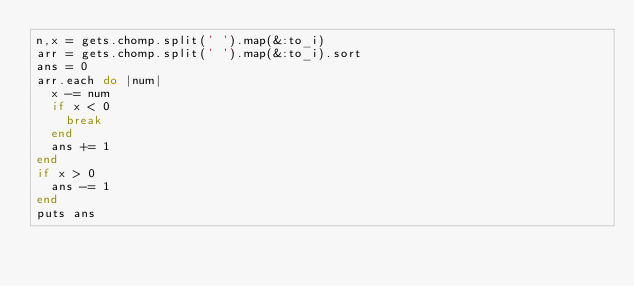Convert code to text. <code><loc_0><loc_0><loc_500><loc_500><_Ruby_>n,x = gets.chomp.split(' ').map(&:to_i)
arr = gets.chomp.split(' ').map(&:to_i).sort
ans = 0
arr.each do |num|
  x -= num
  if x < 0
    break
  end
  ans += 1
end
if x > 0
  ans -= 1
end
puts ans
</code> 